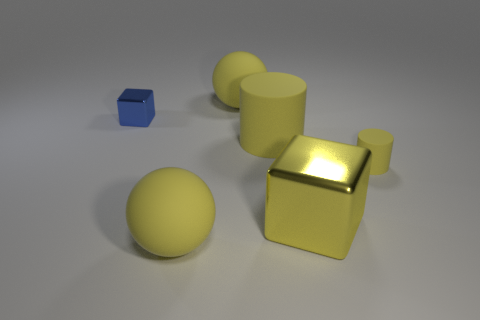Add 3 large rubber cylinders. How many objects exist? 9 Subtract all spheres. How many objects are left? 4 Subtract all large red matte balls. Subtract all tiny rubber objects. How many objects are left? 5 Add 1 big shiny objects. How many big shiny objects are left? 2 Add 5 big rubber spheres. How many big rubber spheres exist? 7 Subtract 0 purple cylinders. How many objects are left? 6 